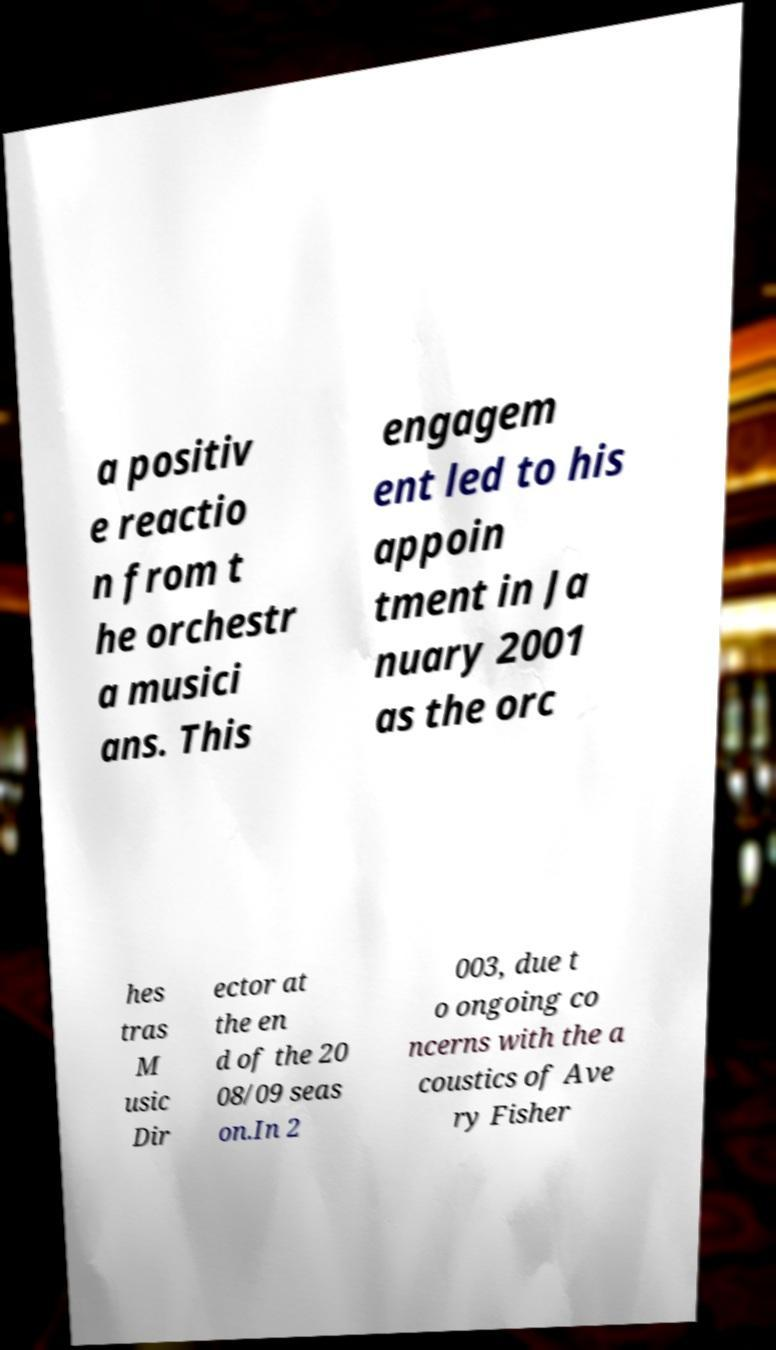I need the written content from this picture converted into text. Can you do that? a positiv e reactio n from t he orchestr a musici ans. This engagem ent led to his appoin tment in Ja nuary 2001 as the orc hes tras M usic Dir ector at the en d of the 20 08/09 seas on.In 2 003, due t o ongoing co ncerns with the a coustics of Ave ry Fisher 